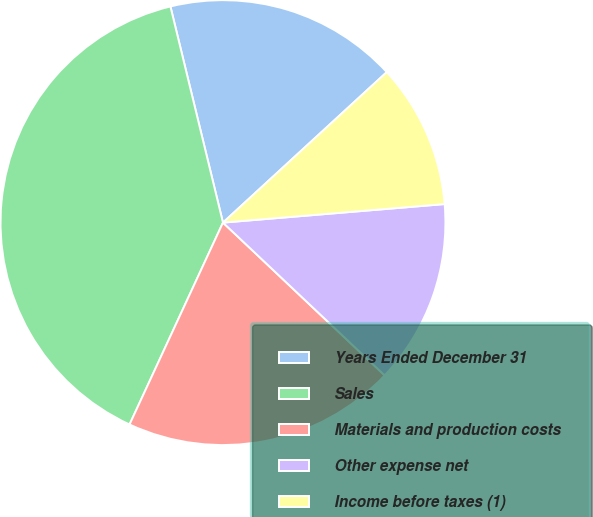Convert chart to OTSL. <chart><loc_0><loc_0><loc_500><loc_500><pie_chart><fcel>Years Ended December 31<fcel>Sales<fcel>Materials and production costs<fcel>Other expense net<fcel>Income before taxes (1)<nl><fcel>16.97%<fcel>39.31%<fcel>19.85%<fcel>13.38%<fcel>10.5%<nl></chart> 